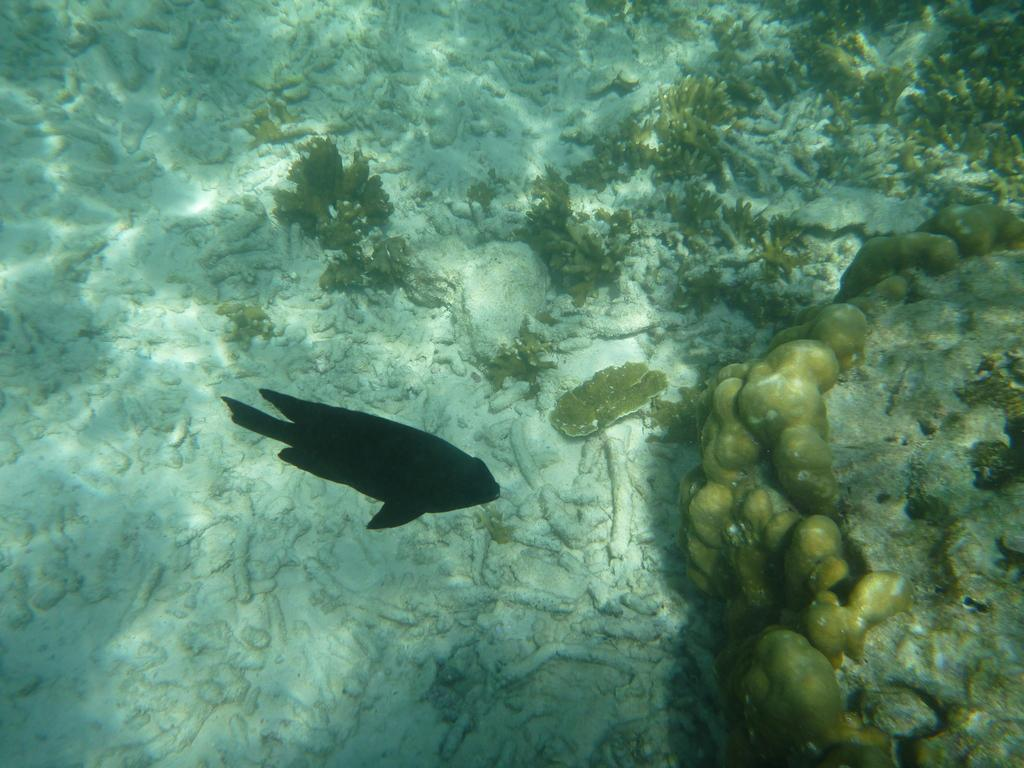What type of environment is shown in the image? The image depicts a water body. What type of animal can be seen in the water? There is a fish present in the water. What can be seen in the background of the image? Aquatic plants and stones are visible in the background of the image. Can you tell me how many beads are attached to the fish in the image? There are no beads attached to the fish in the image; it is a natural fish swimming in the water. Is the fish's aunt visible in the image? There is no reference to an aunt or any other person in the image; it only features a fish in a water body. 